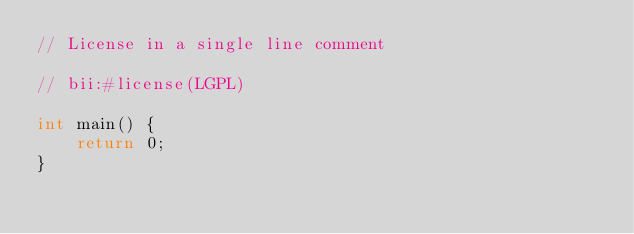Convert code to text. <code><loc_0><loc_0><loc_500><loc_500><_C++_>// License in a single line comment

// bii:#license(LGPL)

int main() {
    return 0;
}</code> 